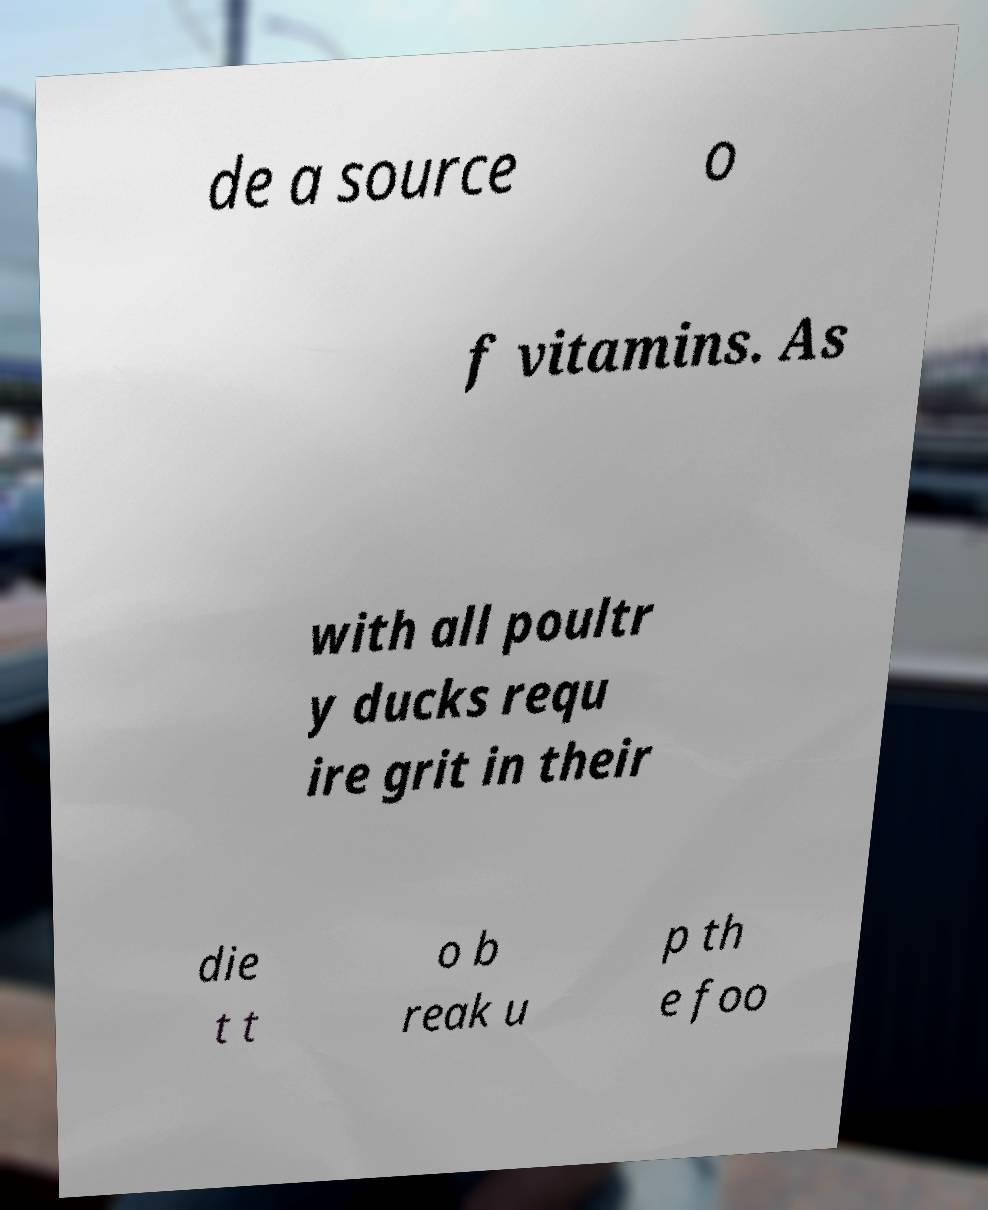Please identify and transcribe the text found in this image. de a source o f vitamins. As with all poultr y ducks requ ire grit in their die t t o b reak u p th e foo 